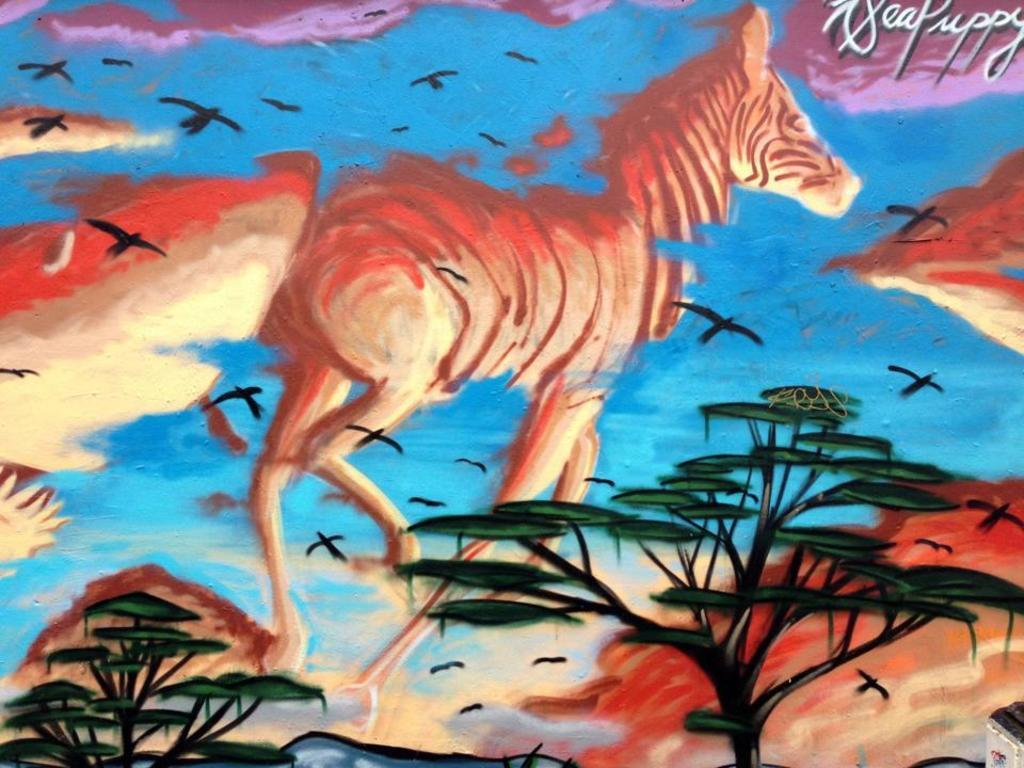What type of artwork is shown in the image? The image is a painting. What animal is the main subject of the painting? The painting depicts a zebra. What else can be seen in the sky in the painting? There are birds flying in the air in the painting. What type of vegetation is at the bottom of the painting? There are plants at the bottom of the painting. What type of chalk is used to draw the zebra in the painting? The image is a painting, not a drawing, so there is no chalk used in its creation. 